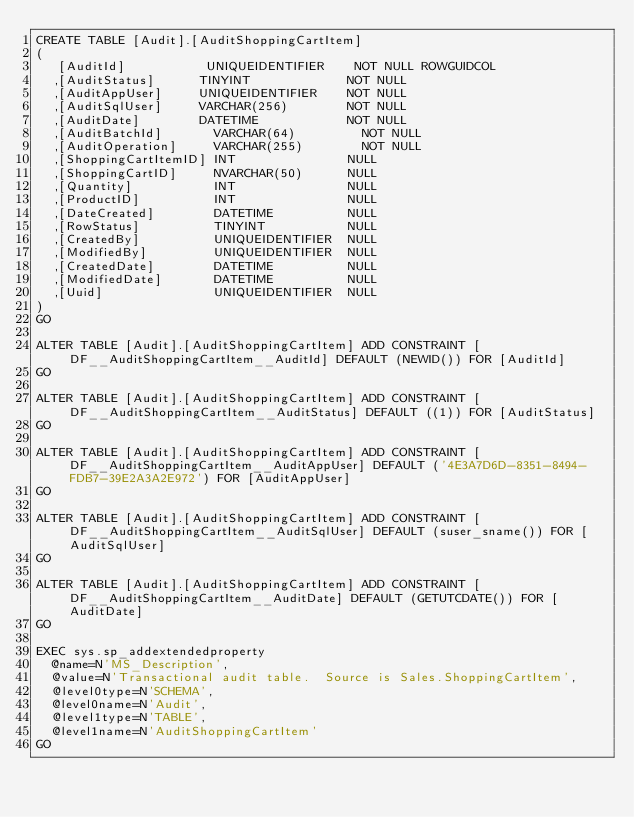<code> <loc_0><loc_0><loc_500><loc_500><_SQL_>CREATE TABLE [Audit].[AuditShoppingCartItem]
(
   [AuditId]           UNIQUEIDENTIFIER    NOT NULL ROWGUIDCOL
  ,[AuditStatus]      TINYINT             NOT NULL
  ,[AuditAppUser]     UNIQUEIDENTIFIER    NOT NULL
  ,[AuditSqlUser]     VARCHAR(256)        NOT NULL
  ,[AuditDate]        DATETIME            NOT NULL
  ,[AuditBatchId]       VARCHAR(64)         NOT NULL
  ,[AuditOperation]     VARCHAR(255)        NOT NULL
  ,[ShoppingCartItemID] INT               NULL
  ,[ShoppingCartID]     NVARCHAR(50)      NULL
  ,[Quantity]           INT               NULL
  ,[ProductID]          INT               NULL
  ,[DateCreated]        DATETIME          NULL
  ,[RowStatus]          TINYINT           NULL
  ,[CreatedBy]          UNIQUEIDENTIFIER  NULL
  ,[ModifiedBy]         UNIQUEIDENTIFIER  NULL
  ,[CreatedDate]        DATETIME          NULL
  ,[ModifiedDate]       DATETIME          NULL
  ,[Uuid]               UNIQUEIDENTIFIER  NULL
)
GO

ALTER TABLE [Audit].[AuditShoppingCartItem] ADD CONSTRAINT [DF__AuditShoppingCartItem__AuditId] DEFAULT (NEWID()) FOR [AuditId]
GO

ALTER TABLE [Audit].[AuditShoppingCartItem] ADD CONSTRAINT [DF__AuditShoppingCartItem__AuditStatus] DEFAULT ((1)) FOR [AuditStatus]
GO

ALTER TABLE [Audit].[AuditShoppingCartItem] ADD CONSTRAINT [DF__AuditShoppingCartItem__AuditAppUser] DEFAULT ('4E3A7D6D-8351-8494-FDB7-39E2A3A2E972') FOR [AuditAppUser]
GO

ALTER TABLE [Audit].[AuditShoppingCartItem] ADD CONSTRAINT [DF__AuditShoppingCartItem__AuditSqlUser] DEFAULT (suser_sname()) FOR [AuditSqlUser]
GO

ALTER TABLE [Audit].[AuditShoppingCartItem] ADD CONSTRAINT [DF__AuditShoppingCartItem__AuditDate] DEFAULT (GETUTCDATE()) FOR [AuditDate]
GO

EXEC sys.sp_addextendedproperty 
  @name=N'MS_Description',
  @value=N'Transactional audit table.  Source is Sales.ShoppingCartItem',
  @level0type=N'SCHEMA',
  @level0name=N'Audit',
  @level1type=N'TABLE',
  @level1name=N'AuditShoppingCartItem'
GO</code> 